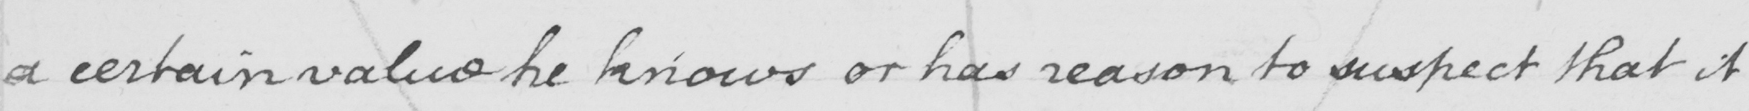Please provide the text content of this handwritten line. a certain value he knows or has reason to suspect that it 